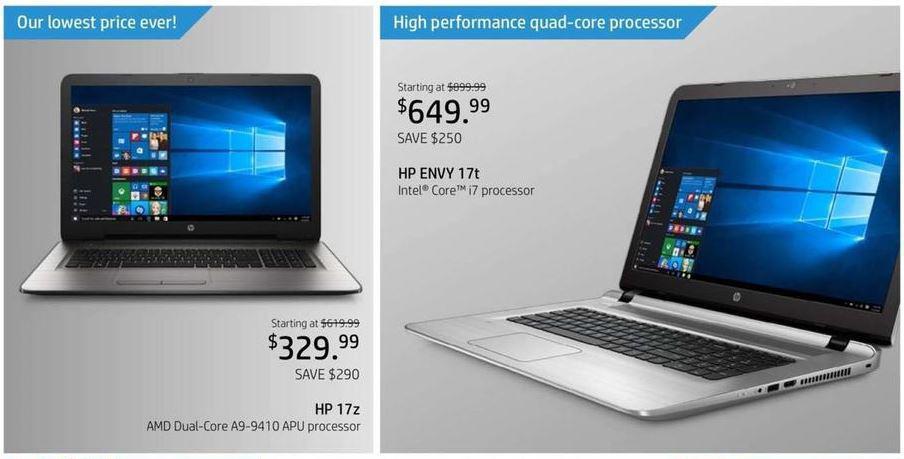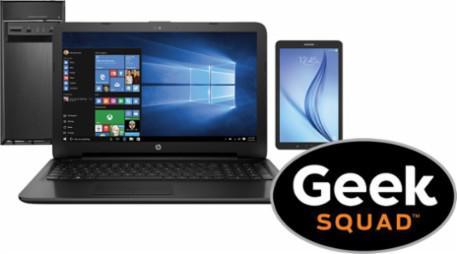The first image is the image on the left, the second image is the image on the right. For the images shown, is this caption "There is one computer in each image." true? Answer yes or no. No. The first image is the image on the left, the second image is the image on the right. Evaluate the accuracy of this statement regarding the images: "The left and right image contains the same number of two in one laptops.". Is it true? Answer yes or no. No. 